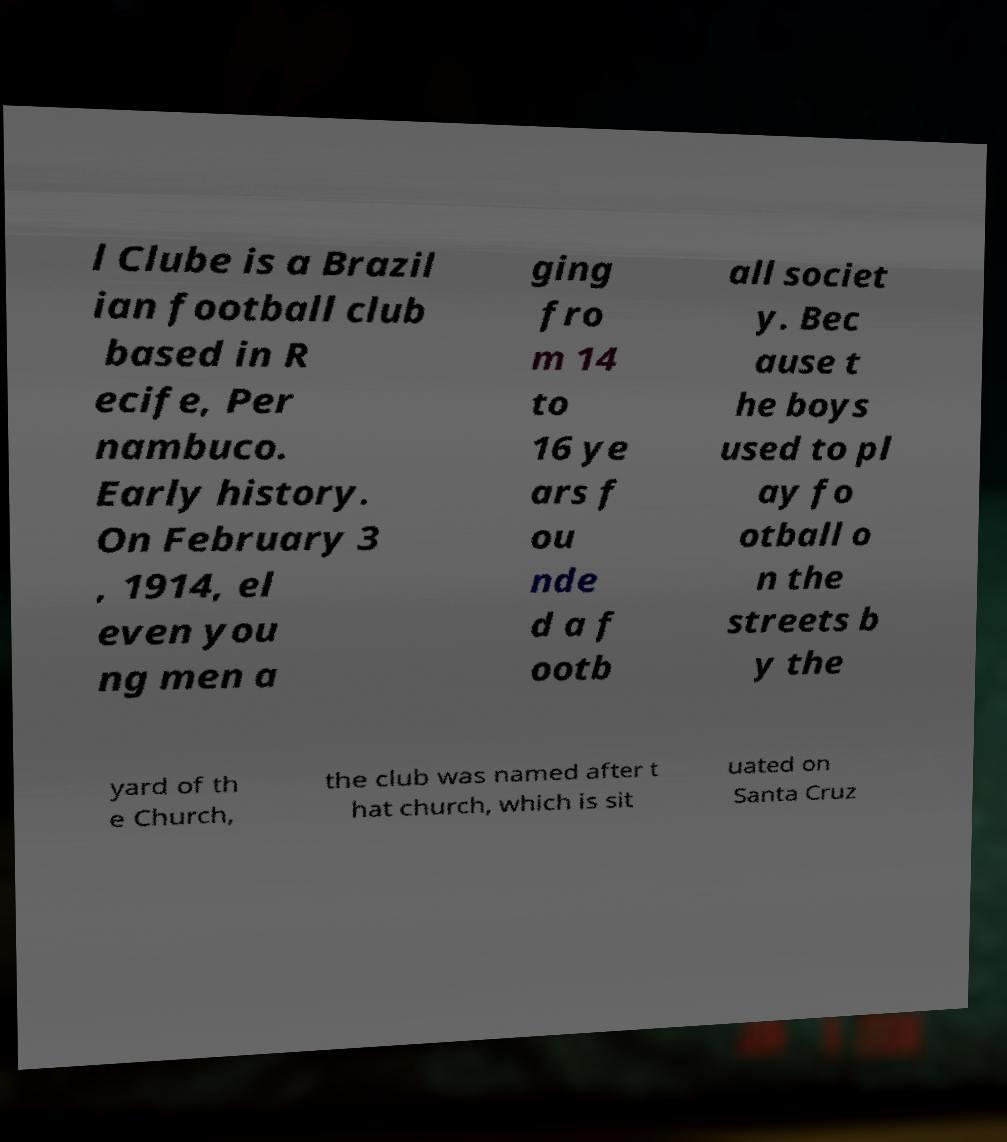Could you extract and type out the text from this image? l Clube is a Brazil ian football club based in R ecife, Per nambuco. Early history. On February 3 , 1914, el even you ng men a ging fro m 14 to 16 ye ars f ou nde d a f ootb all societ y. Bec ause t he boys used to pl ay fo otball o n the streets b y the yard of th e Church, the club was named after t hat church, which is sit uated on Santa Cruz 